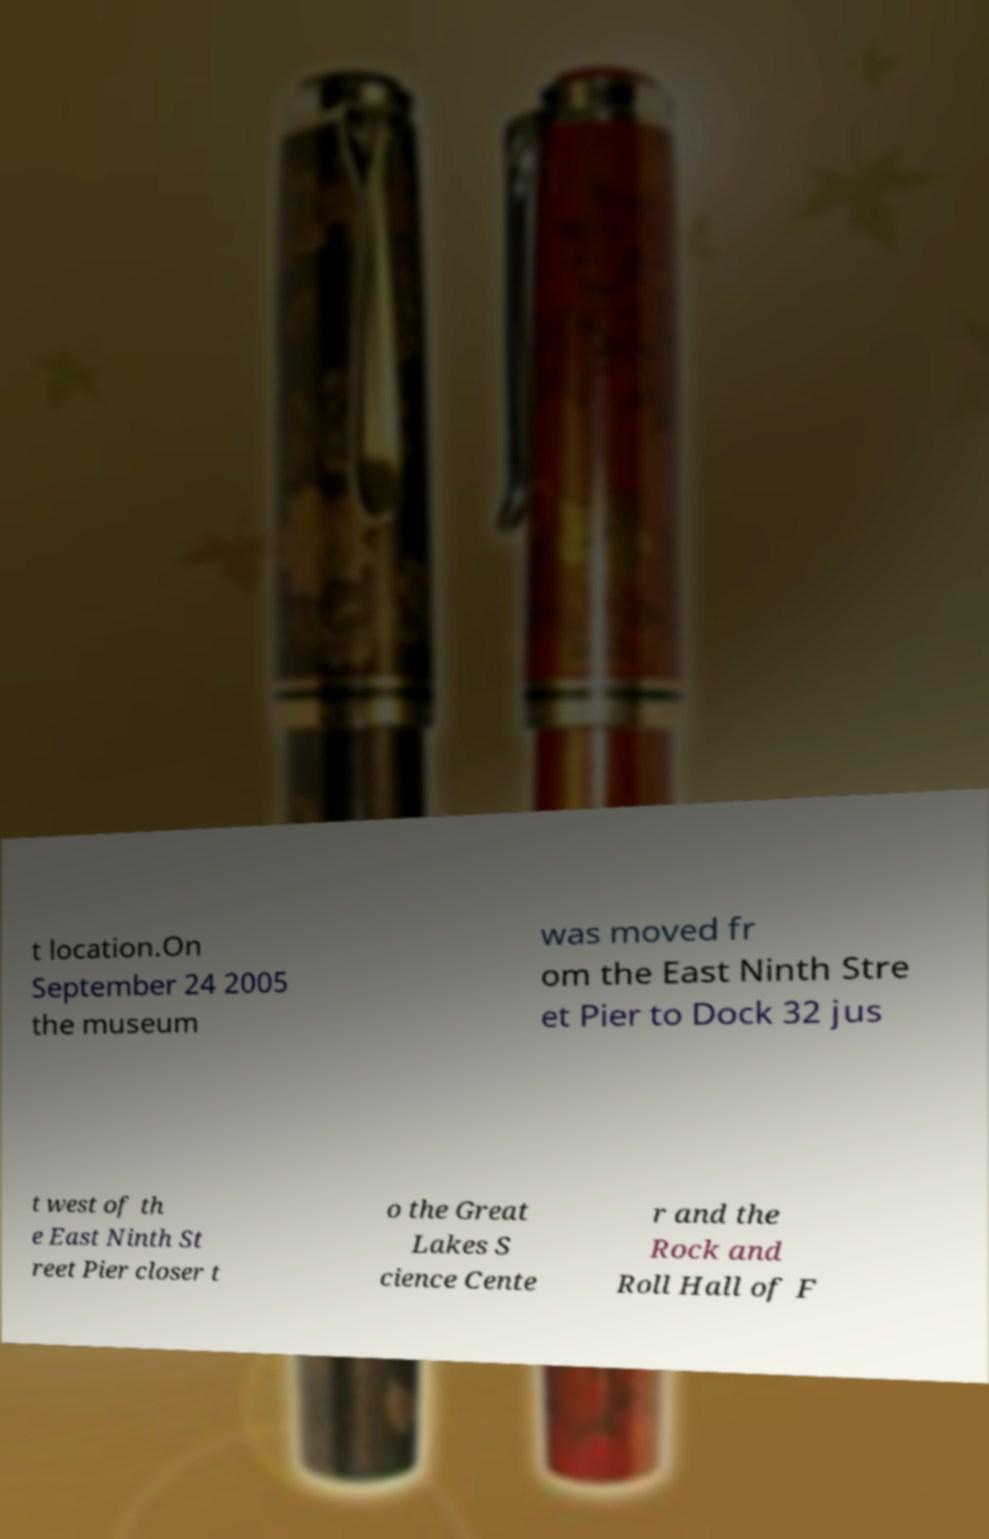Please read and relay the text visible in this image. What does it say? t location.On September 24 2005 the museum was moved fr om the East Ninth Stre et Pier to Dock 32 jus t west of th e East Ninth St reet Pier closer t o the Great Lakes S cience Cente r and the Rock and Roll Hall of F 